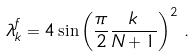<formula> <loc_0><loc_0><loc_500><loc_500>\lambda _ { k } ^ { f } = 4 \sin \left ( \frac { \pi } { 2 } \frac { k } { N + 1 } \right ) ^ { 2 } \, .</formula> 